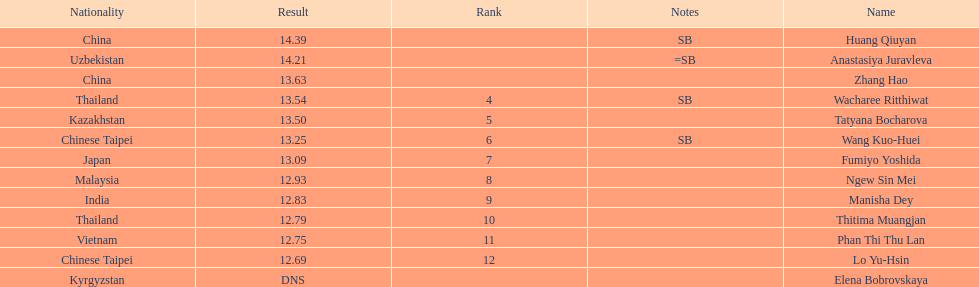How many athletes were from china? 2. 